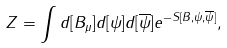<formula> <loc_0><loc_0><loc_500><loc_500>Z = \int d [ B _ { \mu } ] d [ \psi ] d [ \overline { \psi } ] e ^ { - S [ B , \psi , \overline { \psi } ] } ,</formula> 